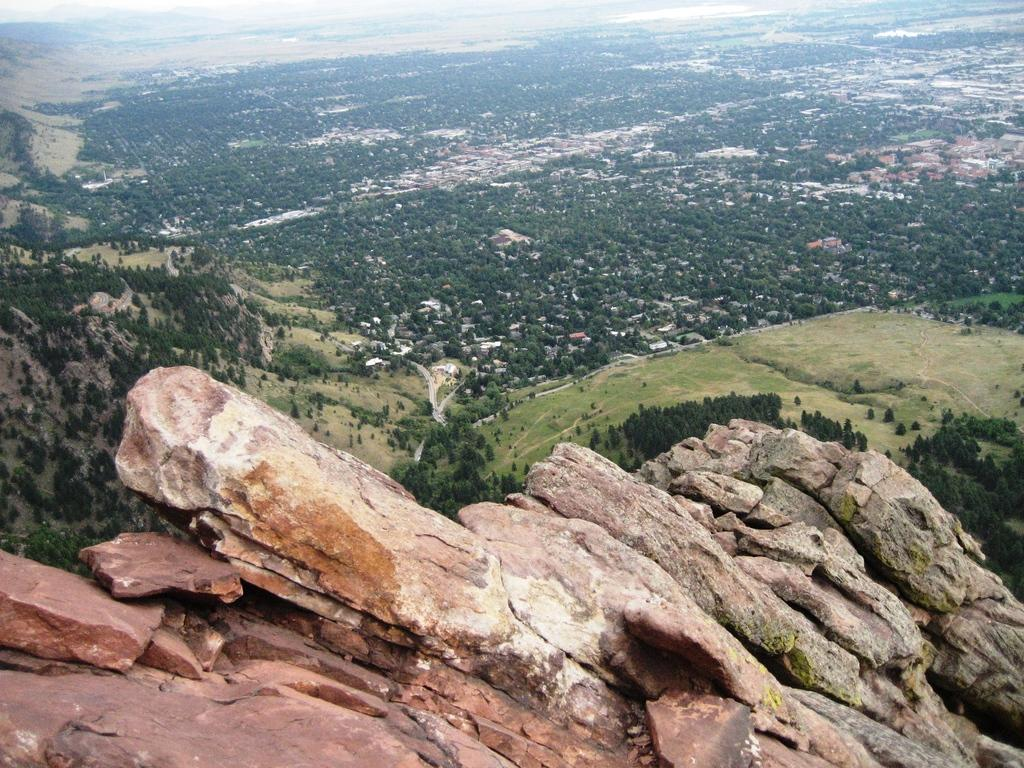What type of natural elements can be seen in the image? There are rocks in the image. What can be seen in the background of the image? There are trees in the background of the image. What type of vase can be seen in the image? There is no vase present in the image. What is the interest rate for the loan mentioned in the image? There is no mention of a loan or interest rate in the image. 